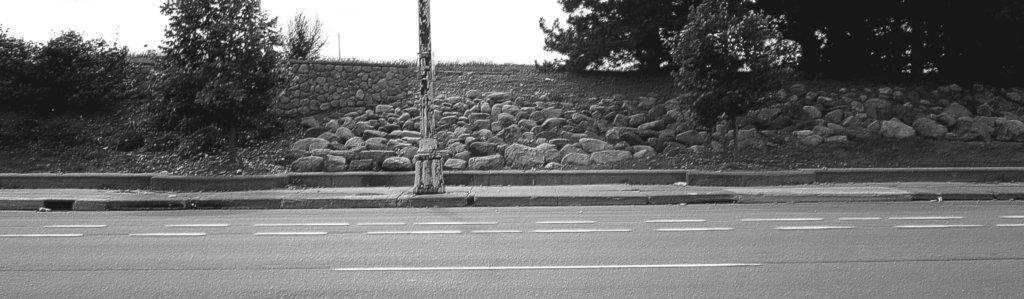Describe this image in one or two sentences. This is black and white image. At the bottom of the image road is there. In the middle of the image one pole, trees and rocks are there. Top of the image sky is present. 